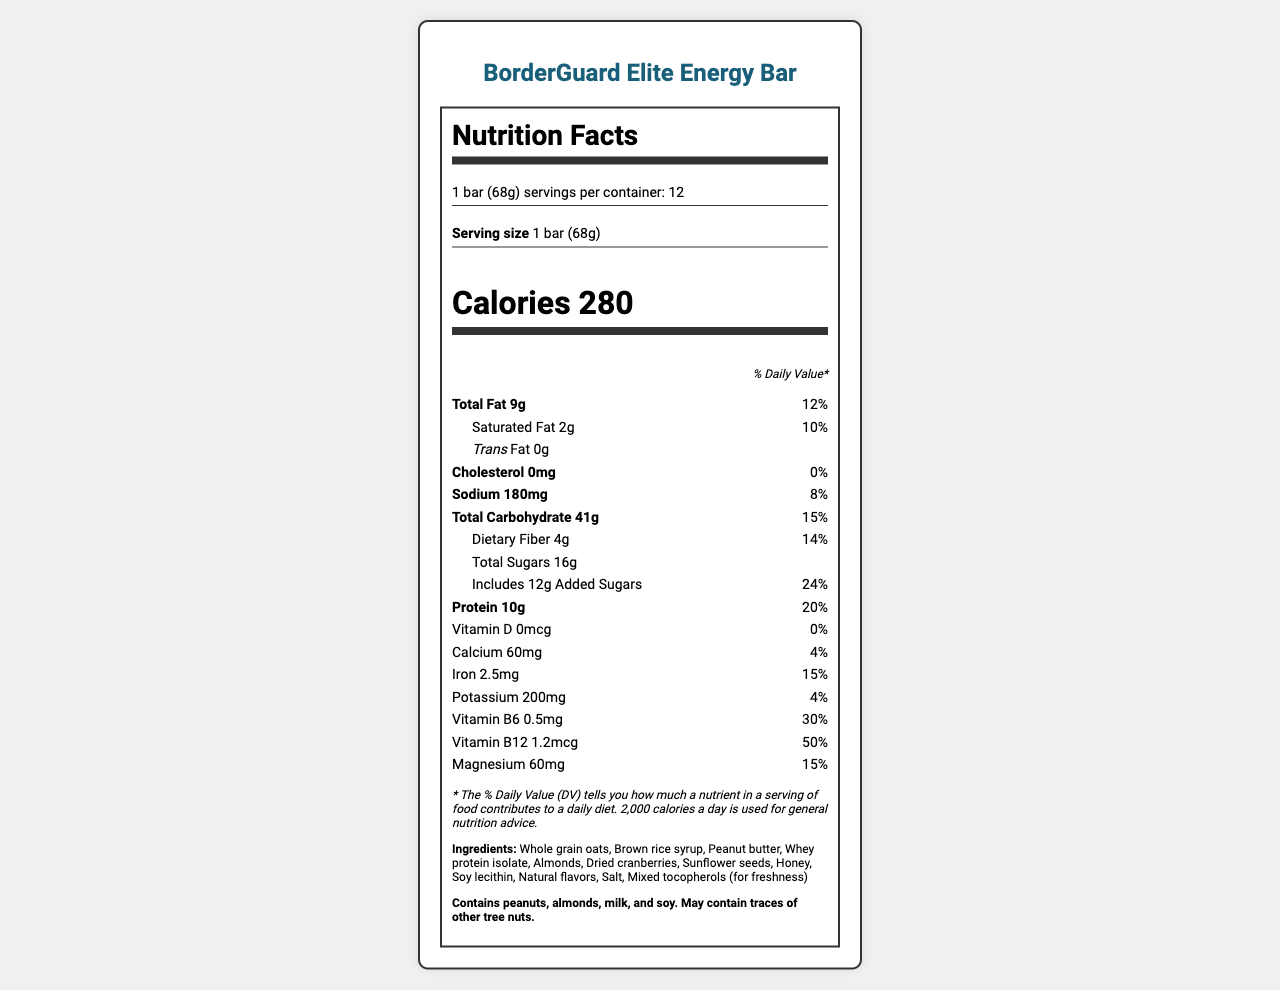what is the serving size of the BorderGuard Elite Energy Bar? The serving size is listed as "1 bar (68g)" in the document.
Answer: 1 bar (68g) how many calories are in one bar? The document states there are 280 calories per serving of 1 bar (68g).
Answer: 280 what is the total amount of fat per serving? The nutrition label lists the total fat content as 9 grams per serving.
Answer: 9g how much protein is in one serving? The amount of protein per serving is 10 grams as indicated on the nutrition label.
Answer: 10g how much added sugar does each bar contain? The label shows that each bar contains 12 grams of added sugars.
Answer: 12g how many servings are there per container? The document mentions that there are 12 servings per container.
Answer: 12 how much fiber does each bar provide? The dietary fiber content per bar is 4 grams according to the nutrition information.
Answer: 4g what percentage of daily value is the iron content? The value for iron is listed as 2.5mg, which is 15% of the daily value.
Answer: 15% Does the product contain any cholesterol? The cholesterol amount is listed as 0mg, indicating it contains no cholesterol.
Answer: No does the energy bar include any tree nuts? The allergen information states the product contains almonds and may contain traces of other tree nuts.
Answer: Yes which vitamin provides the highest percentage of daily value per serving? A. Vitamin D B. Vitamin B6 C. Vitamin B12 D. Magnesium The document lists Vitamin B12 as providing 50% of the daily value per serving, which is higher than the others.
Answer: C. Vitamin B12 how much sodium is in one bar? A. 50 mg B. 120 mg C. 180 mg D. 200 mg The sodium content per bar is listed as 180 mg.
Answer: C. 180 mg which ingredient is mentioned first in the list? A. Brown rice syrup B. Whole grain oats C. Almonds D. Whey protein isolate The first ingredient mentioned in the list is "Whole grain oats".
Answer: B. Whole grain oats is it recommended to store the bars in a cool, dry place? The storage instructions explicitly recommend storing the bars in a cool, dry place.
Answer: Yes can it be determined from the document how long it takes to produce one bar? The document does not provide any details about the production duration of an individual bar.
Answer: Not enough information what is the main purpose of the BorderGuard Elite Energy Bar according to the product description? The product description specifies that the bars are formulated to support border patrol agents by providing sustained energy, vitamins, and minerals.
Answer: To provide sustained energy and essential nutrients for border patrol agents during long surveillance shifts summarize the key features of the BorderGuard Elite Energy Bar. The key features highlight the energy bar's nutritional benefits, sustained energy release, muscle support, cognitive function support, and convenient packaging for field use.
Answer: High in complex carbohydrates for sustained energy release, contains 10g of high-quality protein for muscle support, rich in essential vitamins and minerals for optimal cognitive function, balanced macronutrient profile to maintain satiety during extended shifts, compact and lightweight for easy storage and transport in field gear 